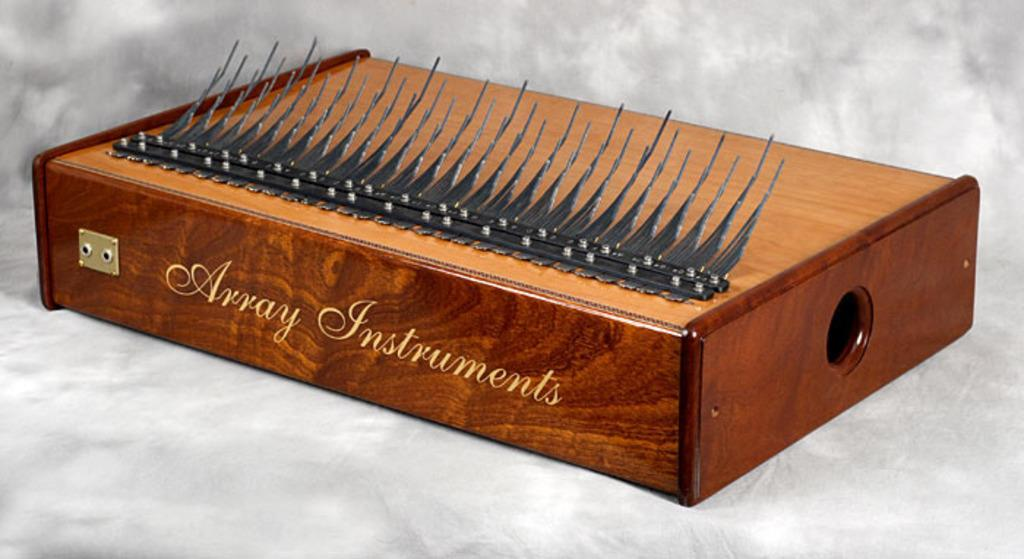What is the main object in the image? There is a wooden box in the image. What can be seen on the wooden box? There is writing on the wooden box. What is placed on top of the wooden box? An item is present on the wooden box. What is the wooden box resting on? The wooden box is on a white object. What type of border is present around the wooden box in the image? There is no mention of a border around the wooden box in the provided facts, so it cannot be determined from the image. 